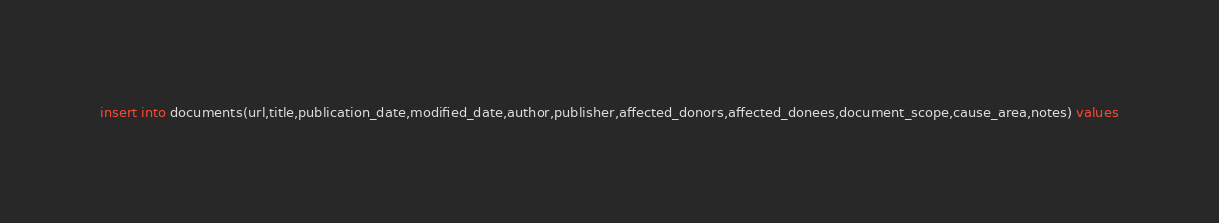<code> <loc_0><loc_0><loc_500><loc_500><_SQL_>insert into documents(url,title,publication_date,modified_date,author,publisher,affected_donors,affected_donees,document_scope,cause_area,notes) values</code> 